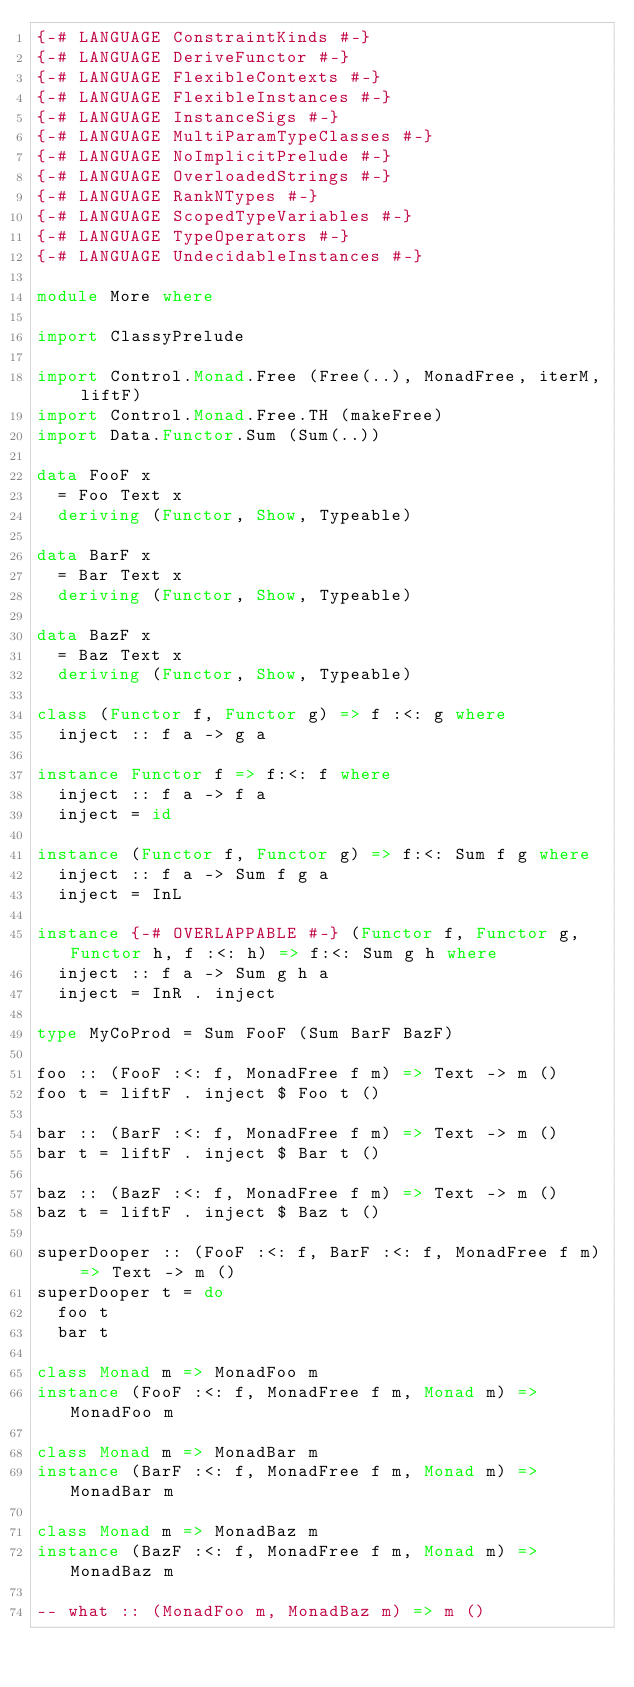Convert code to text. <code><loc_0><loc_0><loc_500><loc_500><_Haskell_>{-# LANGUAGE ConstraintKinds #-}
{-# LANGUAGE DeriveFunctor #-}
{-# LANGUAGE FlexibleContexts #-}
{-# LANGUAGE FlexibleInstances #-}
{-# LANGUAGE InstanceSigs #-}
{-# LANGUAGE MultiParamTypeClasses #-}
{-# LANGUAGE NoImplicitPrelude #-}
{-# LANGUAGE OverloadedStrings #-}
{-# LANGUAGE RankNTypes #-}
{-# LANGUAGE ScopedTypeVariables #-}
{-# LANGUAGE TypeOperators #-}
{-# LANGUAGE UndecidableInstances #-}

module More where

import ClassyPrelude

import Control.Monad.Free (Free(..), MonadFree, iterM, liftF)
import Control.Monad.Free.TH (makeFree)
import Data.Functor.Sum (Sum(..))

data FooF x
  = Foo Text x
  deriving (Functor, Show, Typeable)

data BarF x
  = Bar Text x
  deriving (Functor, Show, Typeable)

data BazF x
  = Baz Text x
  deriving (Functor, Show, Typeable)

class (Functor f, Functor g) => f :<: g where
  inject :: f a -> g a

instance Functor f => f:<: f where
  inject :: f a -> f a
  inject = id

instance (Functor f, Functor g) => f:<: Sum f g where
  inject :: f a -> Sum f g a
  inject = InL

instance {-# OVERLAPPABLE #-} (Functor f, Functor g, Functor h, f :<: h) => f:<: Sum g h where
  inject :: f a -> Sum g h a
  inject = InR . inject

type MyCoProd = Sum FooF (Sum BarF BazF)

foo :: (FooF :<: f, MonadFree f m) => Text -> m ()
foo t = liftF . inject $ Foo t ()

bar :: (BarF :<: f, MonadFree f m) => Text -> m ()
bar t = liftF . inject $ Bar t ()

baz :: (BazF :<: f, MonadFree f m) => Text -> m ()
baz t = liftF . inject $ Baz t ()

superDooper :: (FooF :<: f, BarF :<: f, MonadFree f m) => Text -> m ()
superDooper t = do
  foo t
  bar t

class Monad m => MonadFoo m
instance (FooF :<: f, MonadFree f m, Monad m) => MonadFoo m

class Monad m => MonadBar m
instance (BarF :<: f, MonadFree f m, Monad m) => MonadBar m

class Monad m => MonadBaz m
instance (BazF :<: f, MonadFree f m, Monad m) => MonadBaz m

-- what :: (MonadFoo m, MonadBaz m) => m ()</code> 